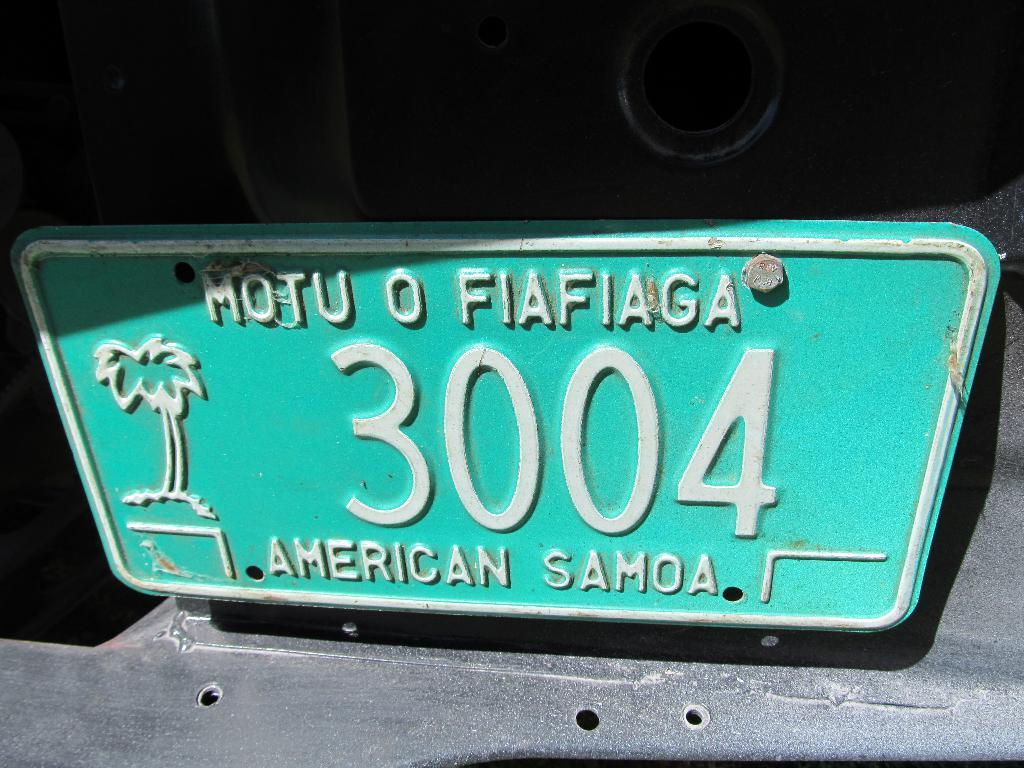Provide a one-sentence caption for the provided image. A faded green license plate for the island of American Samoa. 